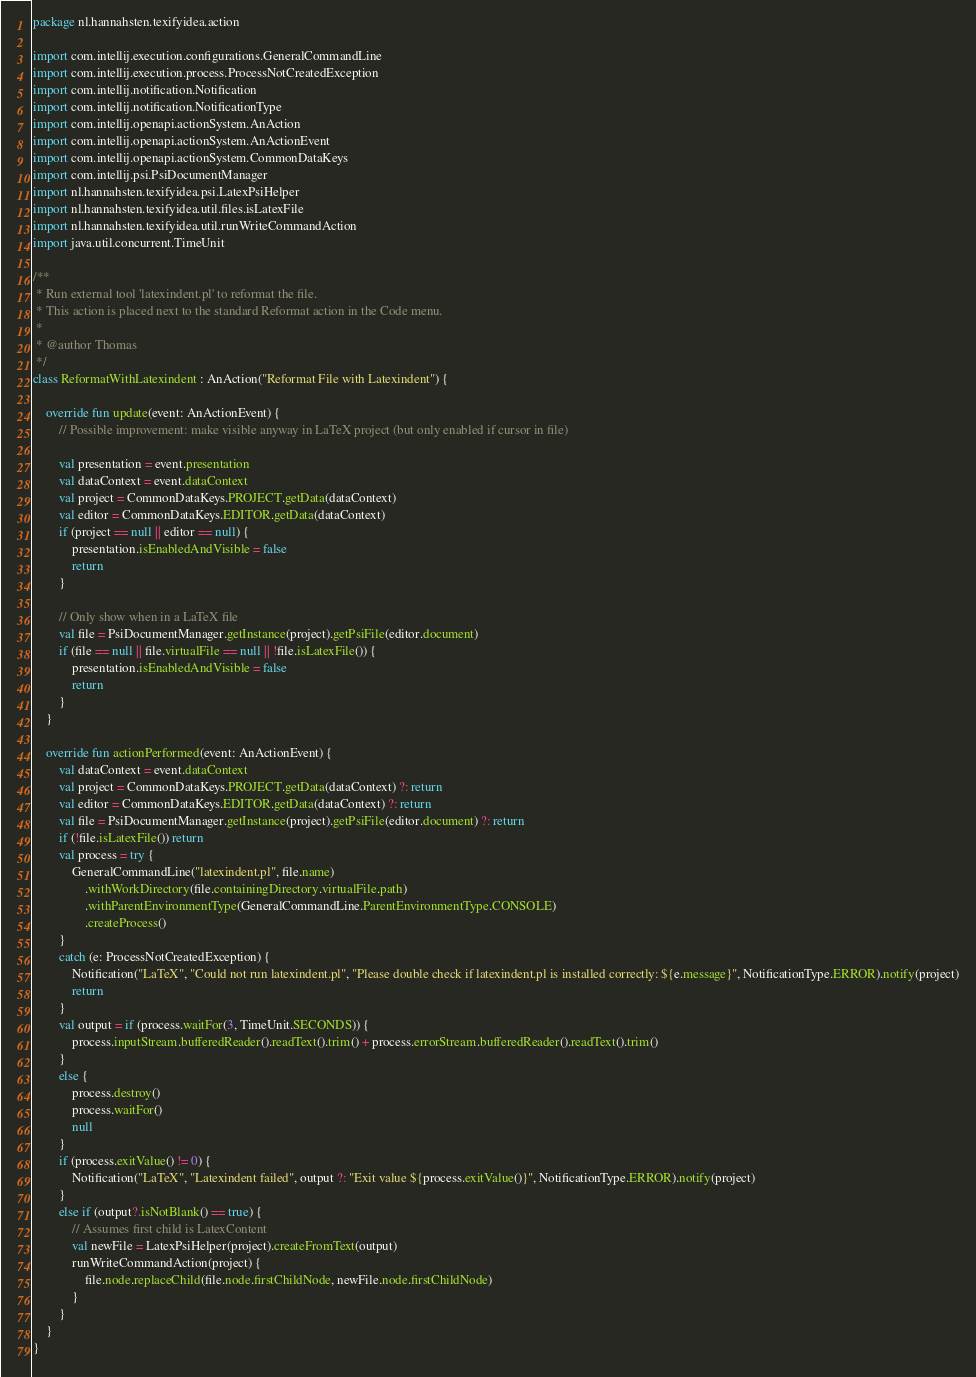<code> <loc_0><loc_0><loc_500><loc_500><_Kotlin_>package nl.hannahsten.texifyidea.action

import com.intellij.execution.configurations.GeneralCommandLine
import com.intellij.execution.process.ProcessNotCreatedException
import com.intellij.notification.Notification
import com.intellij.notification.NotificationType
import com.intellij.openapi.actionSystem.AnAction
import com.intellij.openapi.actionSystem.AnActionEvent
import com.intellij.openapi.actionSystem.CommonDataKeys
import com.intellij.psi.PsiDocumentManager
import nl.hannahsten.texifyidea.psi.LatexPsiHelper
import nl.hannahsten.texifyidea.util.files.isLatexFile
import nl.hannahsten.texifyidea.util.runWriteCommandAction
import java.util.concurrent.TimeUnit

/**
 * Run external tool 'latexindent.pl' to reformat the file.
 * This action is placed next to the standard Reformat action in the Code menu.
 *
 * @author Thomas
 */
class ReformatWithLatexindent : AnAction("Reformat File with Latexindent") {

    override fun update(event: AnActionEvent) {
        // Possible improvement: make visible anyway in LaTeX project (but only enabled if cursor in file)

        val presentation = event.presentation
        val dataContext = event.dataContext
        val project = CommonDataKeys.PROJECT.getData(dataContext)
        val editor = CommonDataKeys.EDITOR.getData(dataContext)
        if (project == null || editor == null) {
            presentation.isEnabledAndVisible = false
            return
        }

        // Only show when in a LaTeX file
        val file = PsiDocumentManager.getInstance(project).getPsiFile(editor.document)
        if (file == null || file.virtualFile == null || !file.isLatexFile()) {
            presentation.isEnabledAndVisible = false
            return
        }
    }

    override fun actionPerformed(event: AnActionEvent) {
        val dataContext = event.dataContext
        val project = CommonDataKeys.PROJECT.getData(dataContext) ?: return
        val editor = CommonDataKeys.EDITOR.getData(dataContext) ?: return
        val file = PsiDocumentManager.getInstance(project).getPsiFile(editor.document) ?: return
        if (!file.isLatexFile()) return
        val process = try {
            GeneralCommandLine("latexindent.pl", file.name)
                .withWorkDirectory(file.containingDirectory.virtualFile.path)
                .withParentEnvironmentType(GeneralCommandLine.ParentEnvironmentType.CONSOLE)
                .createProcess()
        }
        catch (e: ProcessNotCreatedException) {
            Notification("LaTeX", "Could not run latexindent.pl", "Please double check if latexindent.pl is installed correctly: ${e.message}", NotificationType.ERROR).notify(project)
            return
        }
        val output = if (process.waitFor(3, TimeUnit.SECONDS)) {
            process.inputStream.bufferedReader().readText().trim() + process.errorStream.bufferedReader().readText().trim()
        }
        else {
            process.destroy()
            process.waitFor()
            null
        }
        if (process.exitValue() != 0) {
            Notification("LaTeX", "Latexindent failed", output ?: "Exit value ${process.exitValue()}", NotificationType.ERROR).notify(project)
        }
        else if (output?.isNotBlank() == true) {
            // Assumes first child is LatexContent
            val newFile = LatexPsiHelper(project).createFromText(output)
            runWriteCommandAction(project) {
                file.node.replaceChild(file.node.firstChildNode, newFile.node.firstChildNode)
            }
        }
    }
}</code> 